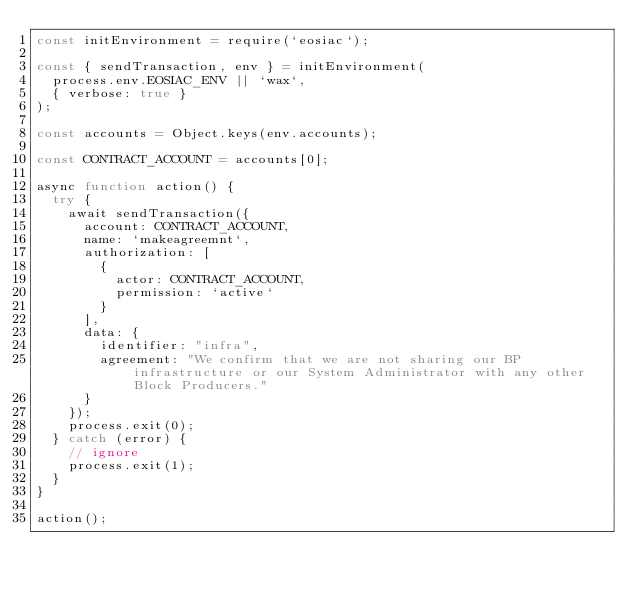<code> <loc_0><loc_0><loc_500><loc_500><_JavaScript_>const initEnvironment = require(`eosiac`);

const { sendTransaction, env } = initEnvironment(
  process.env.EOSIAC_ENV || `wax`,
  { verbose: true }
);

const accounts = Object.keys(env.accounts);

const CONTRACT_ACCOUNT = accounts[0];

async function action() {
  try {
    await sendTransaction({
      account: CONTRACT_ACCOUNT,
      name: `makeagreemnt`,
      authorization: [
        {
          actor: CONTRACT_ACCOUNT,
          permission: `active`
        }
      ],
      data: {
        identifier: "infra",
        agreement: "We confirm that we are not sharing our BP infrastructure or our System Administrator with any other Block Producers."
      }
    });
    process.exit(0);
  } catch (error) {
    // ignore
    process.exit(1);
  }
}

action();
</code> 